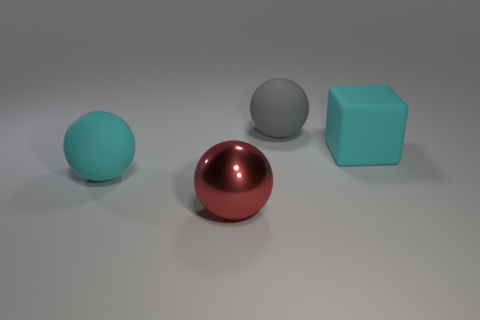What materials are the objects in the image made of, and how can you tell? The objects appear to be made of different materials. The sphere on the left has a matte rubber-like finish, indicating it might be rubber. The smaller sphere has a shiny, reflective surface, suggesting it could be metallic. The object in the middle has a frosted glass look, while the cube on the right appears to have a slightly reflective, yet solid matte finish, which could be plastic or a coated material. 